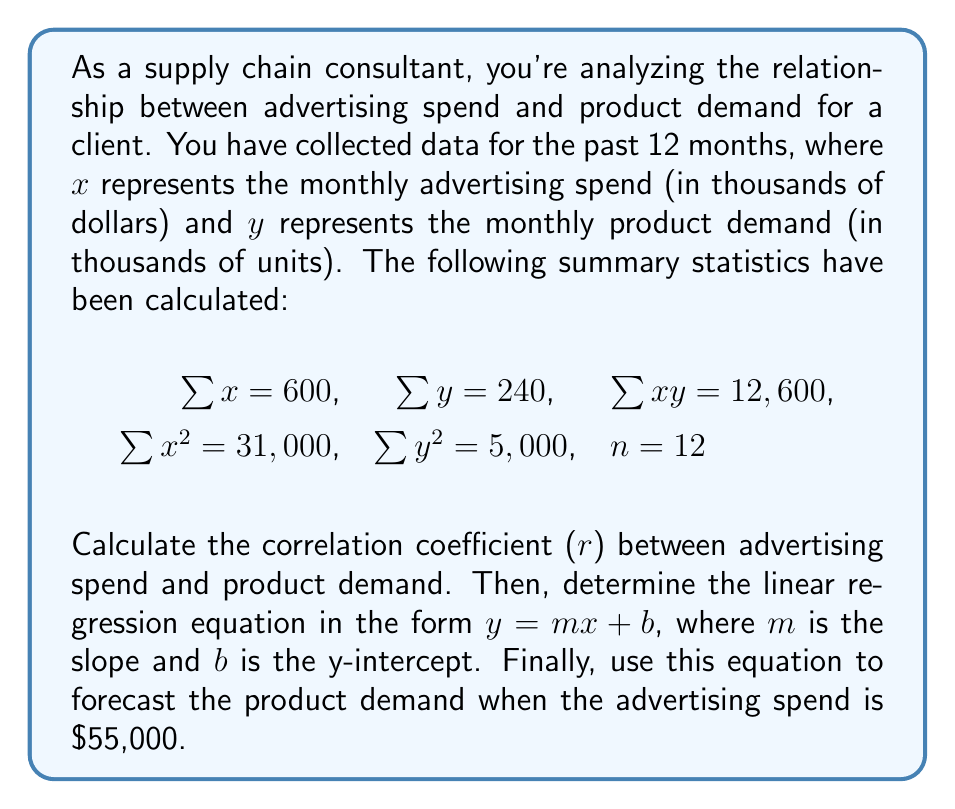Can you solve this math problem? Let's approach this problem step by step:

1. Calculate the correlation coefficient (r):

The formula for the correlation coefficient is:

$$r = \frac{n\sum xy - \sum x \sum y}{\sqrt{[n\sum x^2 - (\sum x)^2][n\sum y^2 - (\sum y)^2]}}$$

Substituting the given values:

$$r = \frac{12(12,600) - (600)(240)}{\sqrt{[12(31,000) - (600)^2][12(5,000) - (240)^2]}}$$

$$r = \frac{151,200 - 144,000}{\sqrt{(372,000 - 360,000)(60,000 - 57,600)}}$$

$$r = \frac{7,200}{\sqrt{(12,000)(2,400)}} = \frac{7,200}{\sqrt{28,800,000}} = \frac{7,200}{5,366.56} \approx 0.9709$$

2. Calculate the linear regression equation:

The slope (m) is given by:

$$m = \frac{n\sum xy - \sum x \sum y}{n\sum x^2 - (\sum x)^2}$$

$$m = \frac{12(12,600) - (600)(240)}{12(31,000) - (600)^2} = \frac{7,200}{12,000} = 0.6$$

The y-intercept (b) is given by:

$$b = \frac{\sum y - m\sum x}{n}$$

$$b = \frac{240 - 0.6(600)}{12} = \frac{240 - 360}{12} = -10$$

Therefore, the linear regression equation is:

$$y = 0.6x - 10$$

3. Forecast the product demand when advertising spend is $55,000:

Substitute x = 55 (since x is in thousands) into the equation:

$$y = 0.6(55) - 10 = 33 - 10 = 23$$
Answer: The correlation coefficient (r) is approximately 0.9709.
The linear regression equation is $y = 0.6x - 10$.
The forecasted product demand when advertising spend is $55,000 is 23,000 units. 